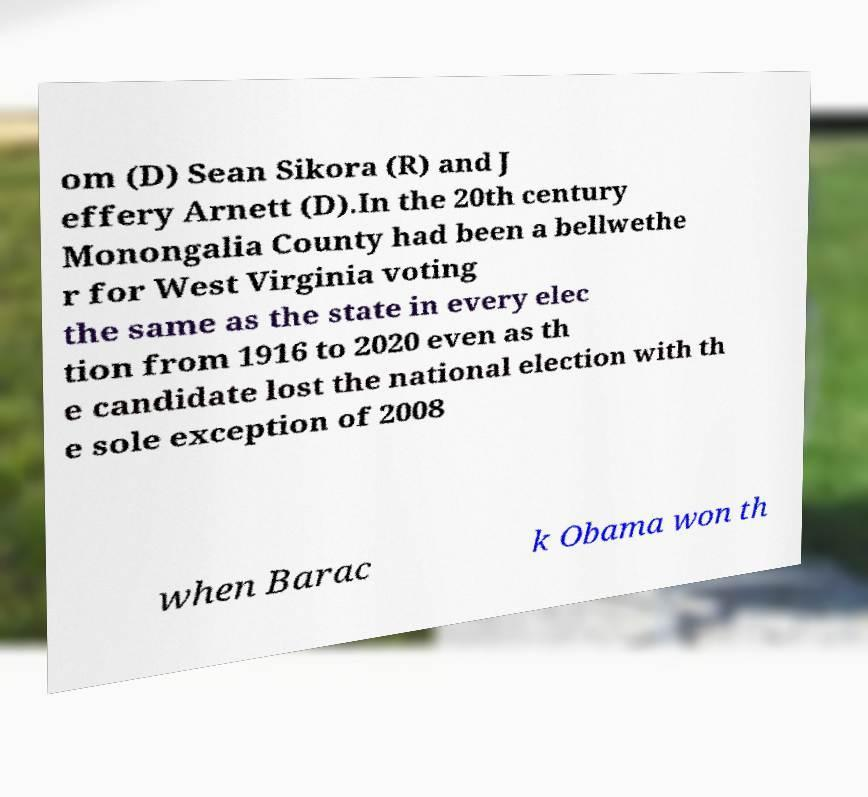Please identify and transcribe the text found in this image. om (D) Sean Sikora (R) and J effery Arnett (D).In the 20th century Monongalia County had been a bellwethe r for West Virginia voting the same as the state in every elec tion from 1916 to 2020 even as th e candidate lost the national election with th e sole exception of 2008 when Barac k Obama won th 